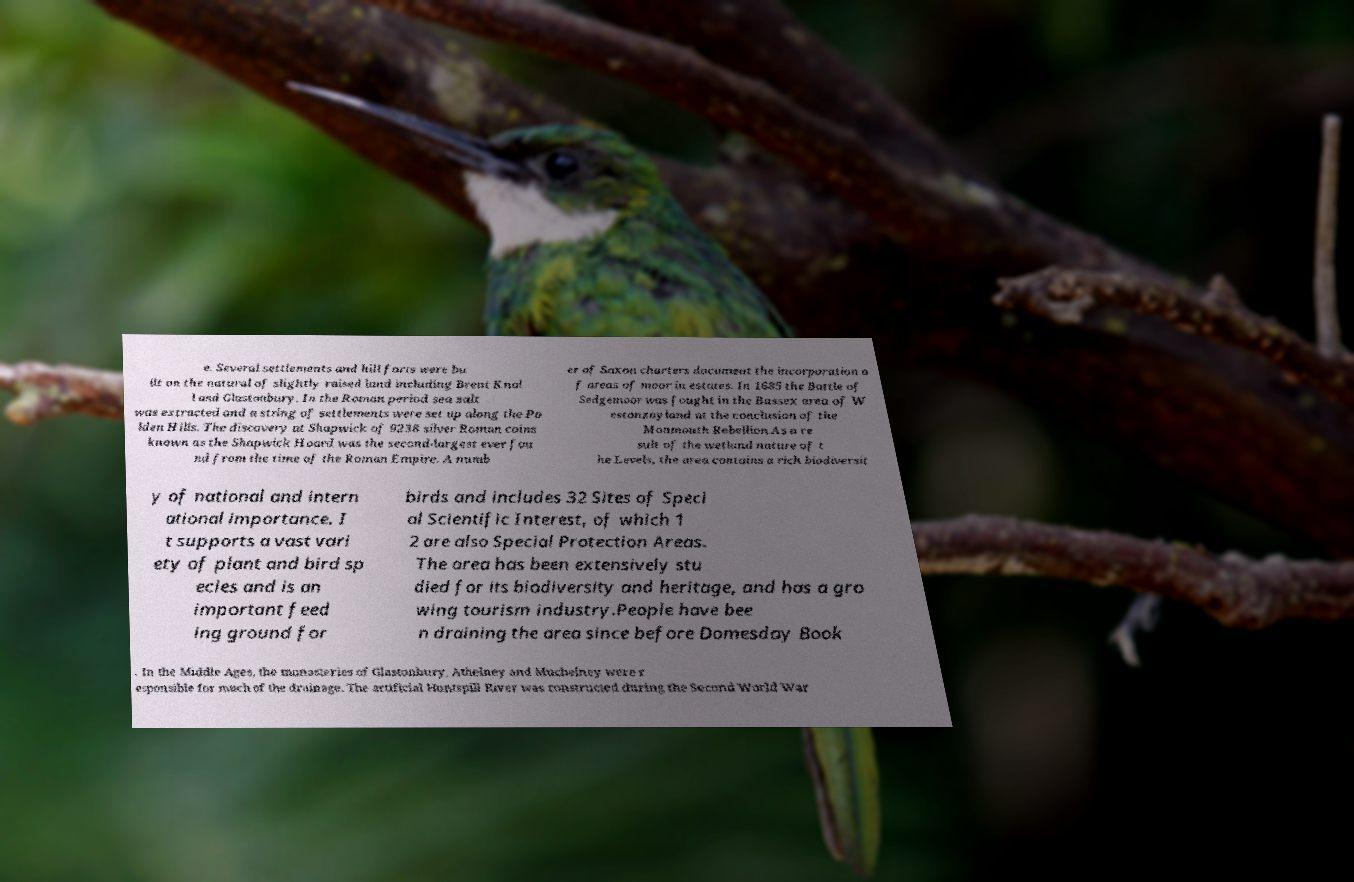What messages or text are displayed in this image? I need them in a readable, typed format. e. Several settlements and hill forts were bu ilt on the natural of slightly raised land including Brent Knol l and Glastonbury. In the Roman period sea salt was extracted and a string of settlements were set up along the Po lden Hills. The discovery at Shapwick of 9238 silver Roman coins known as the Shapwick Hoard was the second-largest ever fou nd from the time of the Roman Empire. A numb er of Saxon charters document the incorporation o f areas of moor in estates. In 1685 the Battle of Sedgemoor was fought in the Bussex area of W estonzoyland at the conclusion of the Monmouth Rebellion.As a re sult of the wetland nature of t he Levels, the area contains a rich biodiversit y of national and intern ational importance. I t supports a vast vari ety of plant and bird sp ecies and is an important feed ing ground for birds and includes 32 Sites of Speci al Scientific Interest, of which 1 2 are also Special Protection Areas. The area has been extensively stu died for its biodiversity and heritage, and has a gro wing tourism industry.People have bee n draining the area since before Domesday Book . In the Middle Ages, the monasteries of Glastonbury, Athelney and Muchelney were r esponsible for much of the drainage. The artificial Huntspill River was constructed during the Second World War 